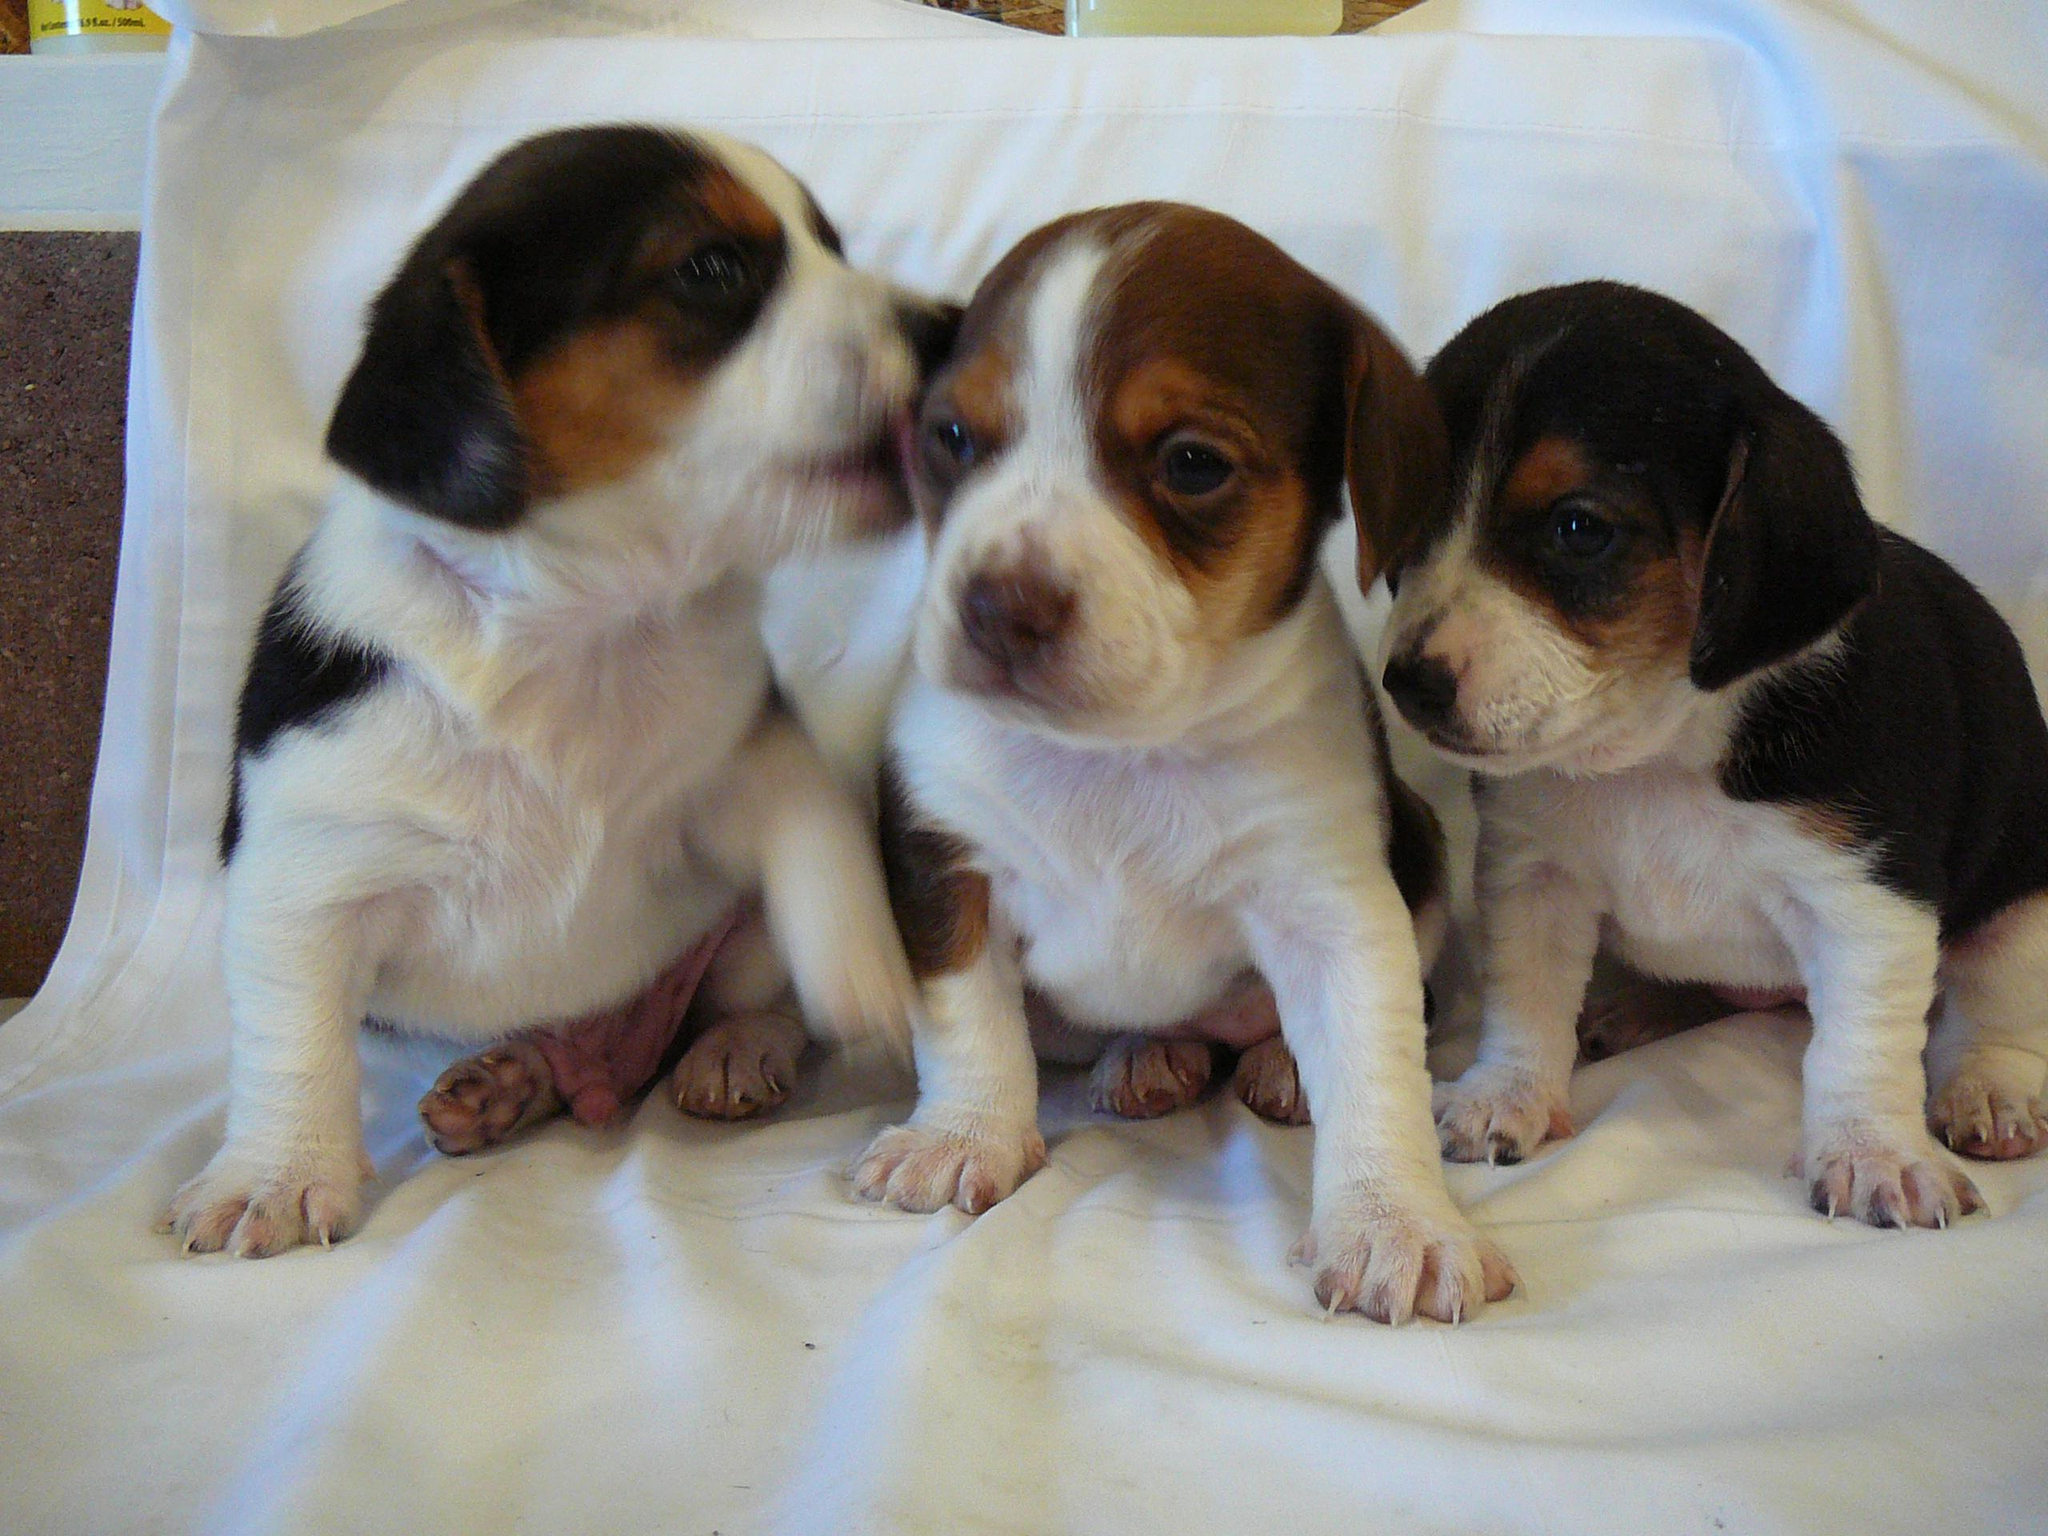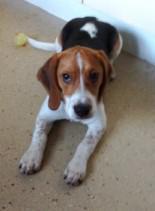The first image is the image on the left, the second image is the image on the right. For the images shown, is this caption "Each image shows one young beagle, and no beagle is in a reclining pose." true? Answer yes or no. No. 